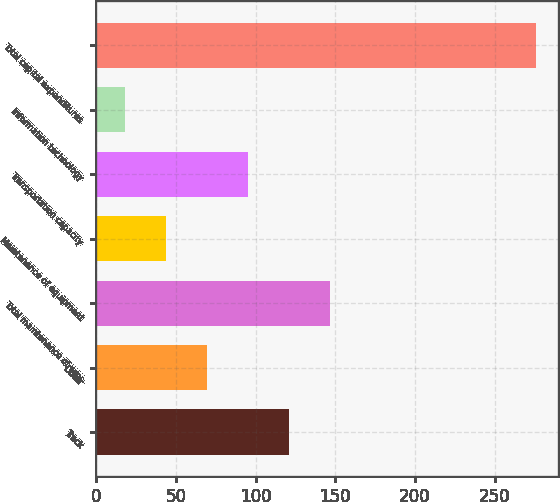Convert chart. <chart><loc_0><loc_0><loc_500><loc_500><bar_chart><fcel>Track<fcel>Other<fcel>Total maintenance of way<fcel>Maintenance of equipment<fcel>Transportation capacity<fcel>Information technology<fcel>Total capital expenditures<nl><fcel>121.14<fcel>69.62<fcel>146.9<fcel>43.86<fcel>95.38<fcel>18.1<fcel>275.7<nl></chart> 